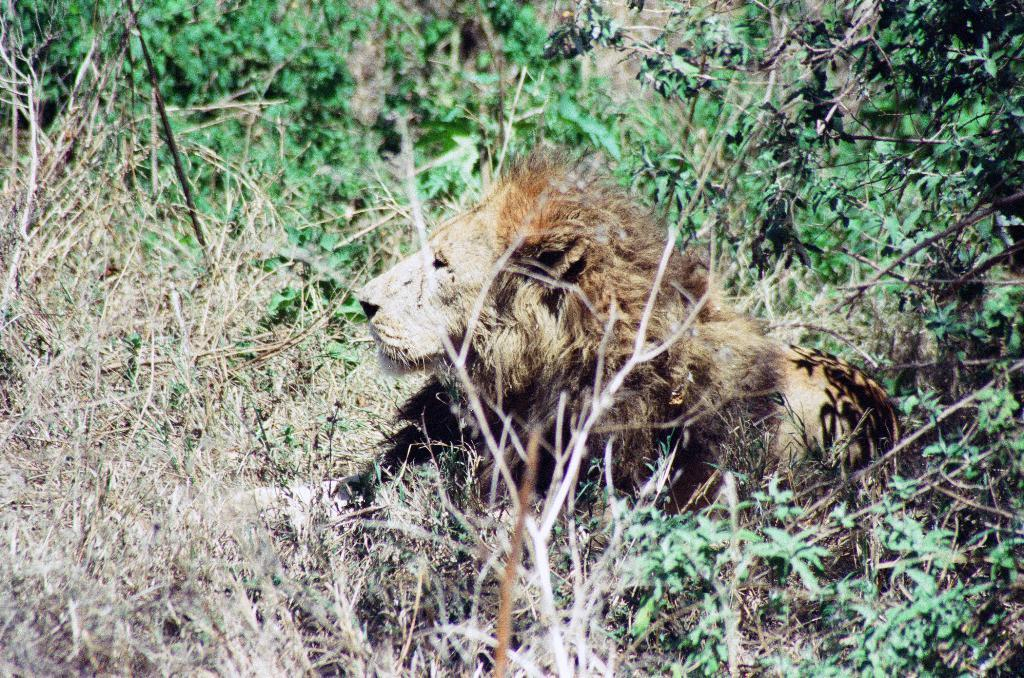What animal is the main subject of the picture? There is a lion in the picture. What is the color of the lion? The lion is brown in color. What type of natural environment is depicted in the picture? There are trees and plants in the picture, suggesting a natural environment. What type of whip is the lion using in the picture? There is no whip present in the picture; the lion is not using any tools or objects. 